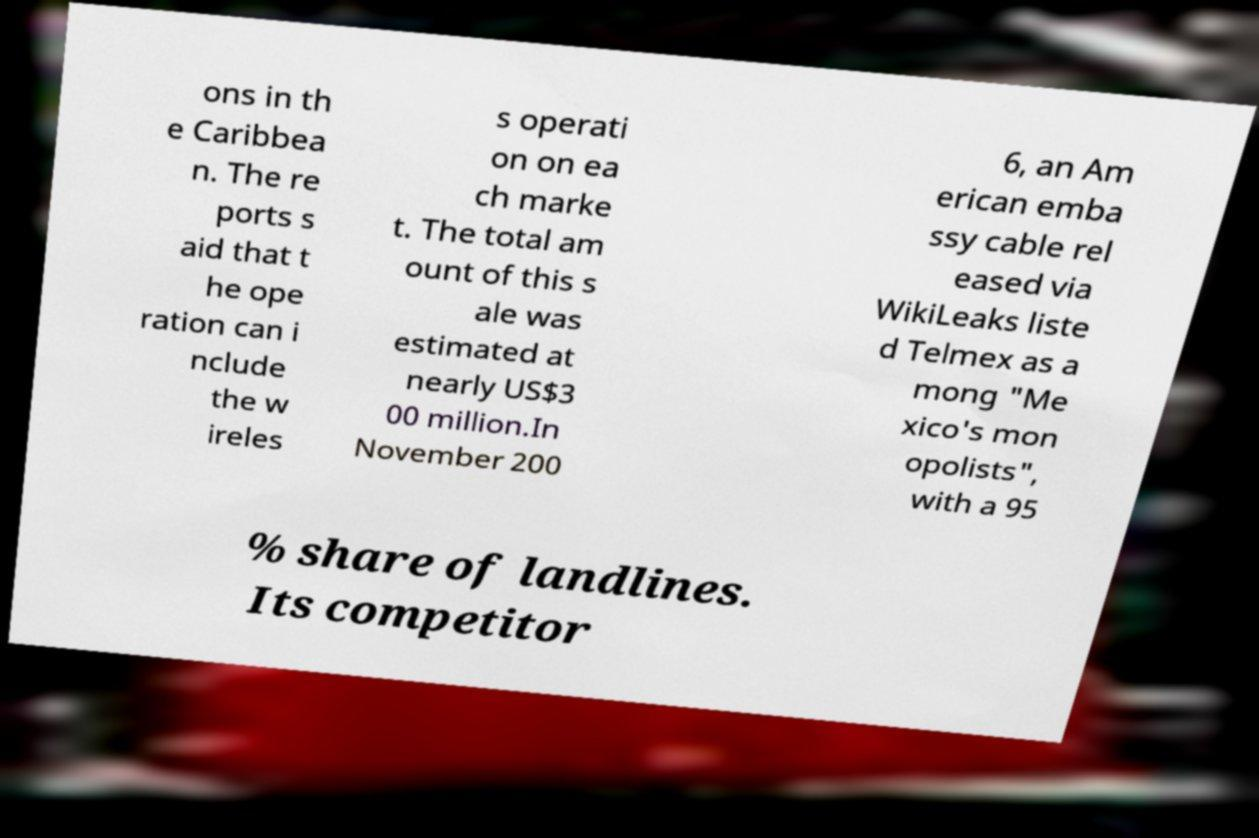There's text embedded in this image that I need extracted. Can you transcribe it verbatim? ons in th e Caribbea n. The re ports s aid that t he ope ration can i nclude the w ireles s operati on on ea ch marke t. The total am ount of this s ale was estimated at nearly US$3 00 million.In November 200 6, an Am erican emba ssy cable rel eased via WikiLeaks liste d Telmex as a mong "Me xico's mon opolists", with a 95 % share of landlines. Its competitor 